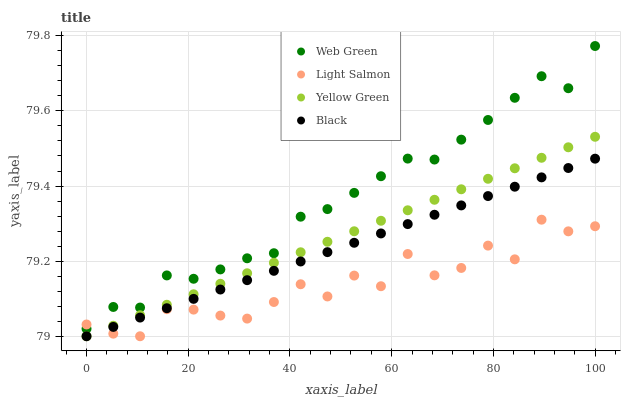Does Light Salmon have the minimum area under the curve?
Answer yes or no. Yes. Does Web Green have the maximum area under the curve?
Answer yes or no. Yes. Does Black have the minimum area under the curve?
Answer yes or no. No. Does Black have the maximum area under the curve?
Answer yes or no. No. Is Yellow Green the smoothest?
Answer yes or no. Yes. Is Light Salmon the roughest?
Answer yes or no. Yes. Is Black the smoothest?
Answer yes or no. No. Is Black the roughest?
Answer yes or no. No. Does Light Salmon have the lowest value?
Answer yes or no. Yes. Does Web Green have the lowest value?
Answer yes or no. No. Does Web Green have the highest value?
Answer yes or no. Yes. Does Black have the highest value?
Answer yes or no. No. Is Black less than Web Green?
Answer yes or no. Yes. Is Web Green greater than Black?
Answer yes or no. Yes. Does Black intersect Light Salmon?
Answer yes or no. Yes. Is Black less than Light Salmon?
Answer yes or no. No. Is Black greater than Light Salmon?
Answer yes or no. No. Does Black intersect Web Green?
Answer yes or no. No. 